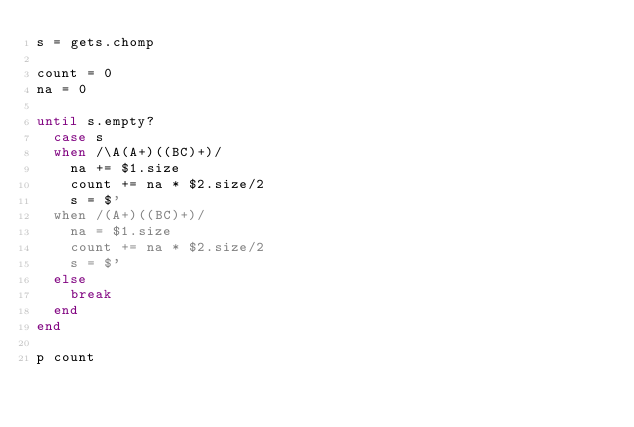Convert code to text. <code><loc_0><loc_0><loc_500><loc_500><_Ruby_>s = gets.chomp

count = 0
na = 0

until s.empty?
  case s
  when /\A(A+)((BC)+)/
    na += $1.size
    count += na * $2.size/2
    s = $'
  when /(A+)((BC)+)/
    na = $1.size
    count += na * $2.size/2
    s = $'
  else
    break
  end
end

p count
</code> 